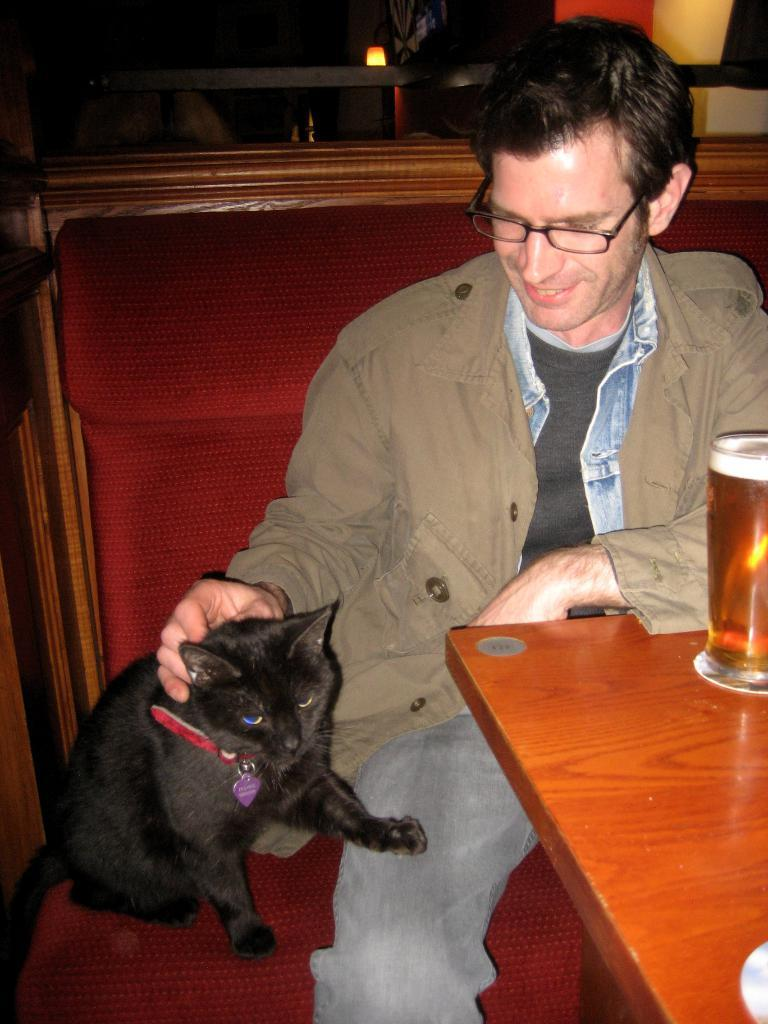What is the main subject of the image? There is a person in the image. What is the person doing in the image? The person is smiling and holding a cat. What is the person sitting on in the image? The person is sitting on a chair. What is present in front of the person? There is a table in front of the person. What can be seen on the table? There is a glass on the table. What type of cake is being served in the church in the image? There is no church or cake present in the image; it features a person sitting on a chair, holding a cat, and a table with a glass on it. 